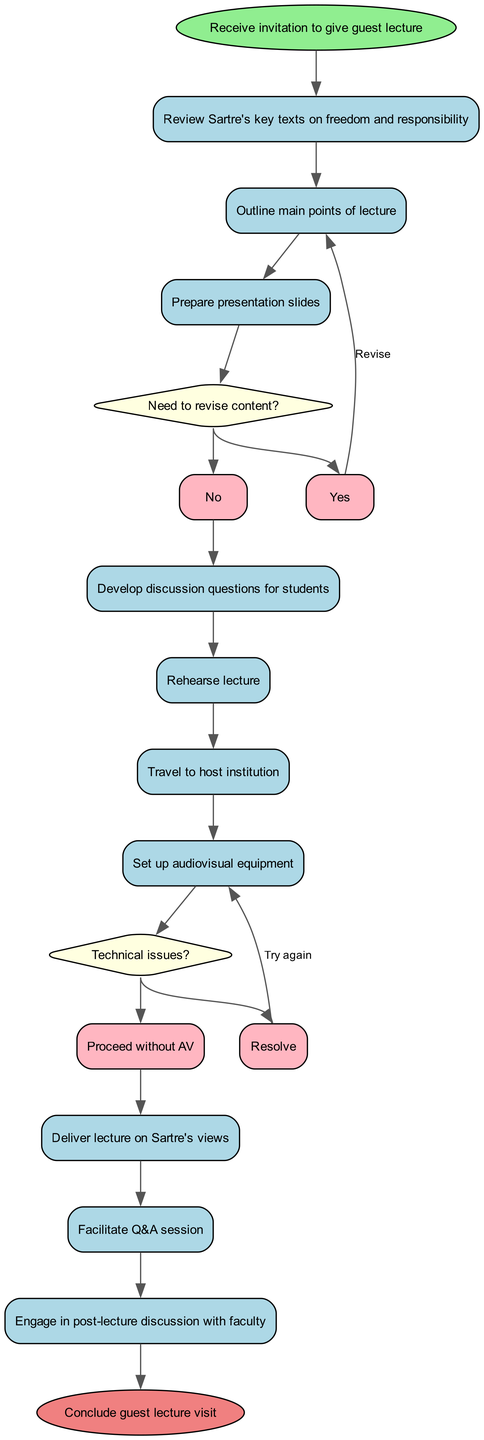What is the first activity in the process? The diagram starts with the "Receive invitation to give guest lecture" node, indicating that this is the initial activity in the process.
Answer: Receive invitation to give guest lecture How many activities are there in total? Counting all the activities listed in the diagram, there are ten activities depicted, including both primary and decision-making activities.
Answer: 10 What is the last node in the diagram? The final node connected in the process is the "Conclude guest lecture visit," which signifies the end of the guest lecture preparation and delivery process.
Answer: Conclude guest lecture visit What happens after "Prepare presentation slides" if the content does not need revision? If the content does not need revision, the flow continues directly to the next activity, which is "Develop discussion questions for students."
Answer: Develop discussion questions for students How many decision nodes are present in the diagram? There are two decision nodes illustrated in the diagram, each representing different points where a choice must be made.
Answer: 2 If there are technical issues during the setup, what is the next step? If technical issues arise, the next step is to "Resolve" those issues and attempt to set up the audiovisual equipment again before proceeding.
Answer: Resolve Which activity leads directly to the decision node about revising content? The activity that directly precedes the decision node regarding content revision is "Prepare presentation slides," indicating it is the point where a choice must be made based on the content prepared.
Answer: Prepare presentation slides What must be done after "Set up audiovisual equipment" if technical issues exist? If technical issues are encountered, the process loops back to "Set up audiovisual equipment" again, indicating an attempt to resolve the issues before proceeding.
Answer: Set up audiovisual equipment What is the purpose of the "Facilitate Q&A session" activity? The "Facilitate Q&A session" is focused on allowing engagement and discussion between the lecturer and students about Sartre's views after delivering the lecture.
Answer: Engage in post-lecture discussion with faculty 